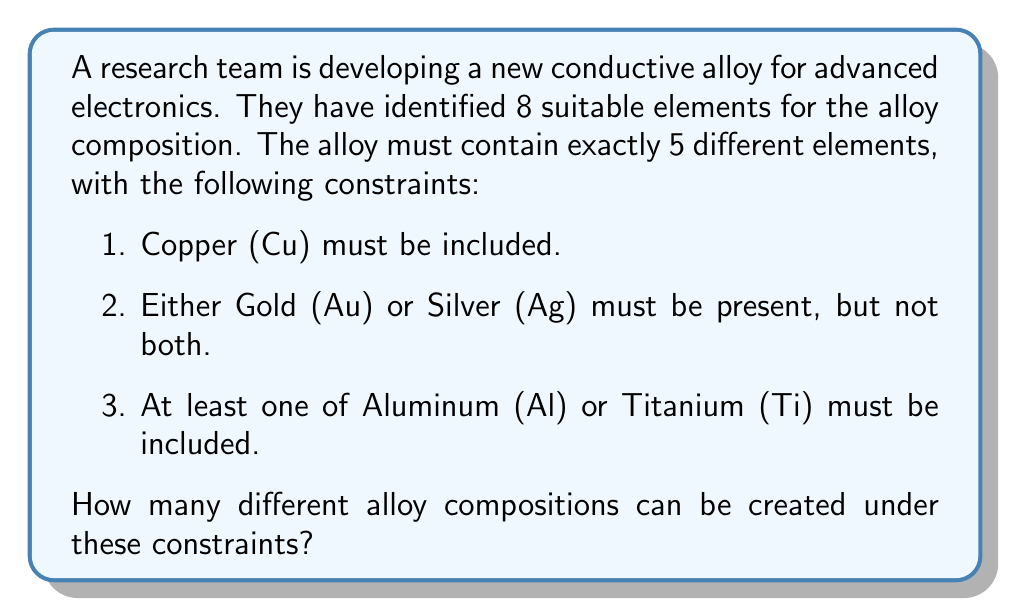Teach me how to tackle this problem. Let's approach this step-by-step:

1) First, we know that Copper (Cu) must be included, so we have 1 element fixed.

2) For the second constraint, we have two cases:
   Case A: Gold (Au) is included
   Case B: Silver (Ag) is included

3) For the third constraint, we have three possibilities:
   - Only Aluminum (Al) is included
   - Only Titanium (Ti) is included
   - Both Aluminum (Al) and Titanium (Ti) are included

4) Let's calculate for Case A (Gold included):
   - If only Al is included: We need to choose 2 more elements from the remaining 3 elements.
     This can be done in $\binom{3}{2} = 3$ ways.
   - If only Ti is included: Similar to above, $\binom{3}{2} = 3$ ways.
   - If both Al and Ti are included: We need to choose 1 more element from the remaining 3 elements.
     This can be done in $\binom{3}{1} = 3$ ways.

5) The total number of compositions for Case A is thus $3 + 3 + 3 = 9$.

6) Case B (Silver included) will have the same number of compositions as Case A.

7) Therefore, the total number of possible alloy compositions is $9 + 9 = 18$.

This can also be represented mathematically as:

$$2 \cdot \left(\binom{3}{2} + \binom{3}{2} + \binom{3}{1}\right) = 2 \cdot (3 + 3 + 3) = 18$$

Where the factor of 2 represents the choice between Au and Ag.
Answer: 18 possible alloy compositions 